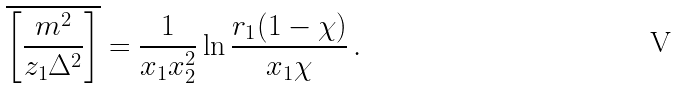<formula> <loc_0><loc_0><loc_500><loc_500>\overline { \left [ \frac { m ^ { 2 } } { z _ { 1 } \Delta ^ { 2 } } \right ] } = \frac { 1 } { x _ { 1 } x _ { 2 } ^ { 2 } } \ln \frac { r _ { 1 } ( 1 - \chi ) } { x _ { 1 } \chi } \, .</formula> 